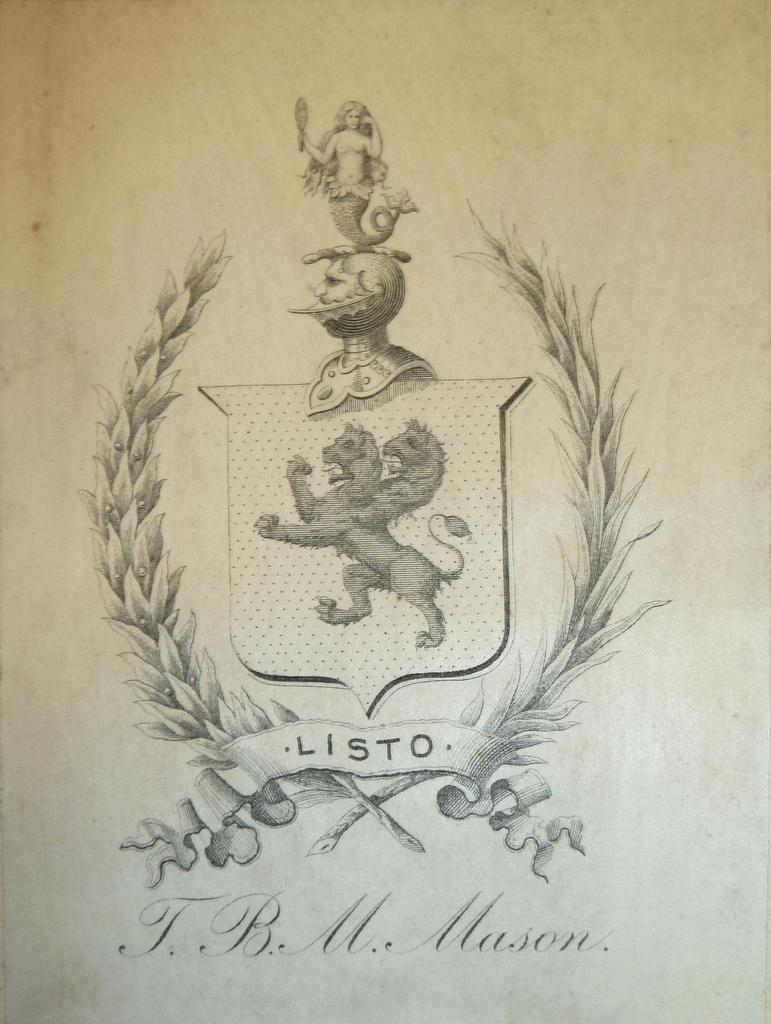What is the main subject of the image? The main subject of the image is a painting of a logo. Where is the logo located in the image? The logo is in the middle of the image. What else can be seen at the bottom of the image? There is text written in the bottom of the image. How many wheels are visible in the image? There are no wheels present in the image. What type of pen is used to write the text at the bottom of the image? There is no pen visible in the image, and the method of writing the text is not specified. 